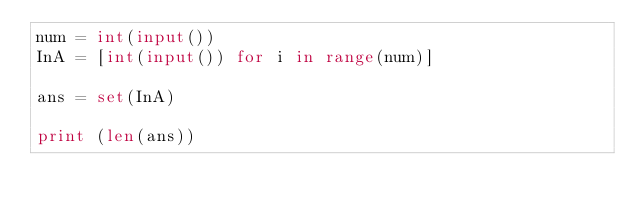Convert code to text. <code><loc_0><loc_0><loc_500><loc_500><_Python_>num = int(input())
InA = [int(input()) for i in range(num)]

ans = set(InA)

print (len(ans))</code> 